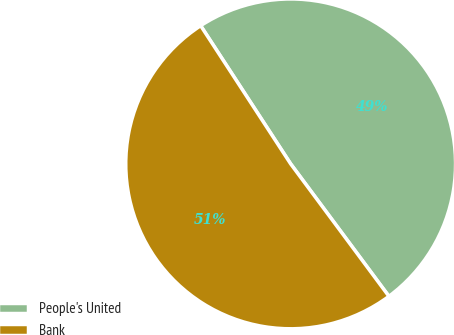Convert chart. <chart><loc_0><loc_0><loc_500><loc_500><pie_chart><fcel>People's United<fcel>Bank<nl><fcel>49.03%<fcel>50.97%<nl></chart> 